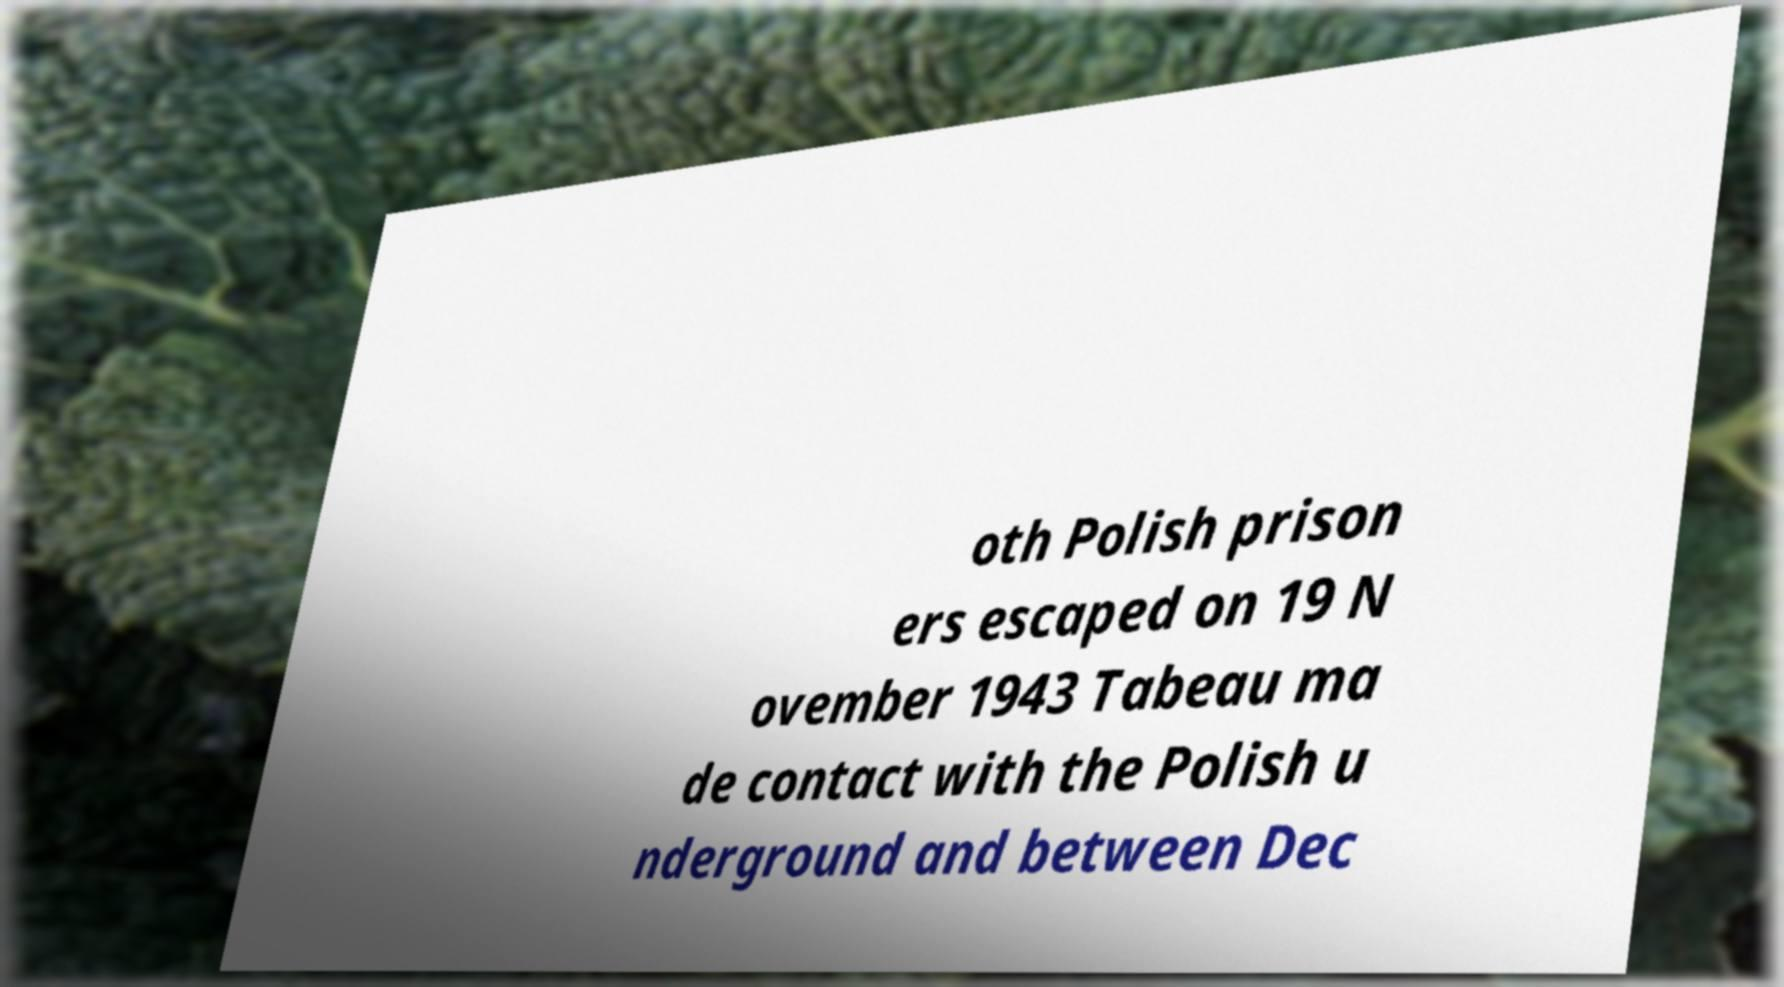Please identify and transcribe the text found in this image. oth Polish prison ers escaped on 19 N ovember 1943 Tabeau ma de contact with the Polish u nderground and between Dec 